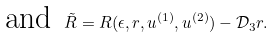<formula> <loc_0><loc_0><loc_500><loc_500>\text { and } \, \tilde { R } = R ( \epsilon , r , u ^ { ( 1 ) } , u ^ { ( 2 ) } ) - \mathcal { D } _ { 3 } r .</formula> 